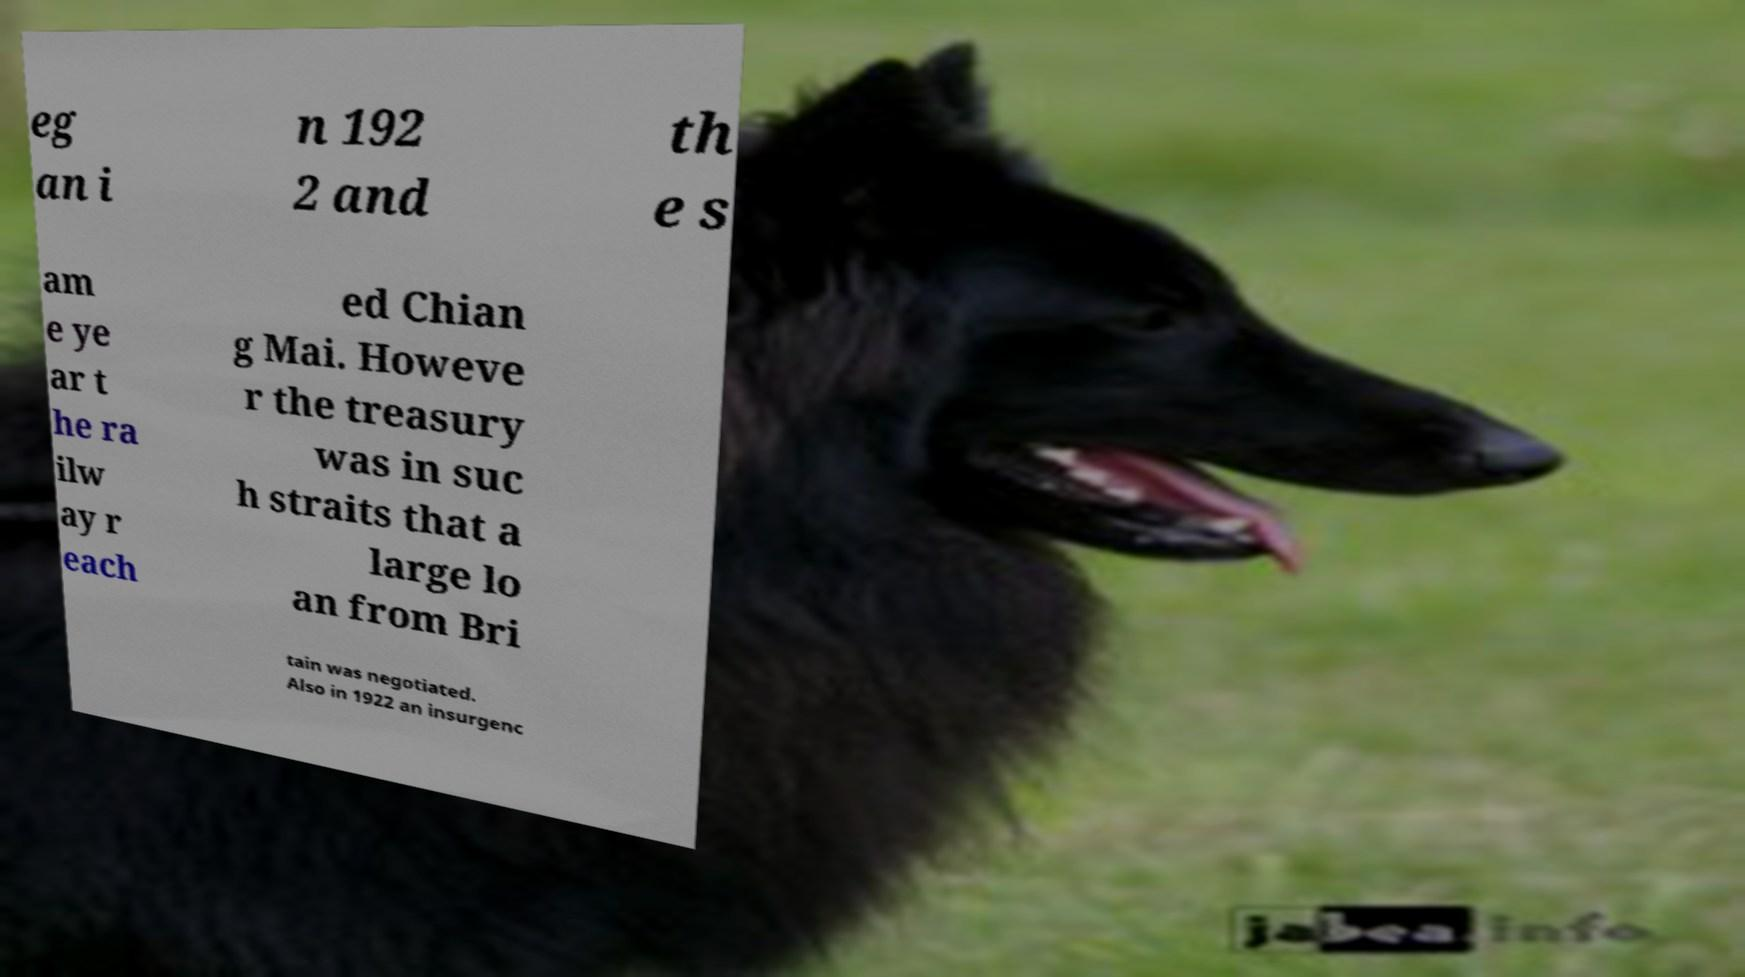Can you read and provide the text displayed in the image?This photo seems to have some interesting text. Can you extract and type it out for me? eg an i n 192 2 and th e s am e ye ar t he ra ilw ay r each ed Chian g Mai. Howeve r the treasury was in suc h straits that a large lo an from Bri tain was negotiated. Also in 1922 an insurgenc 